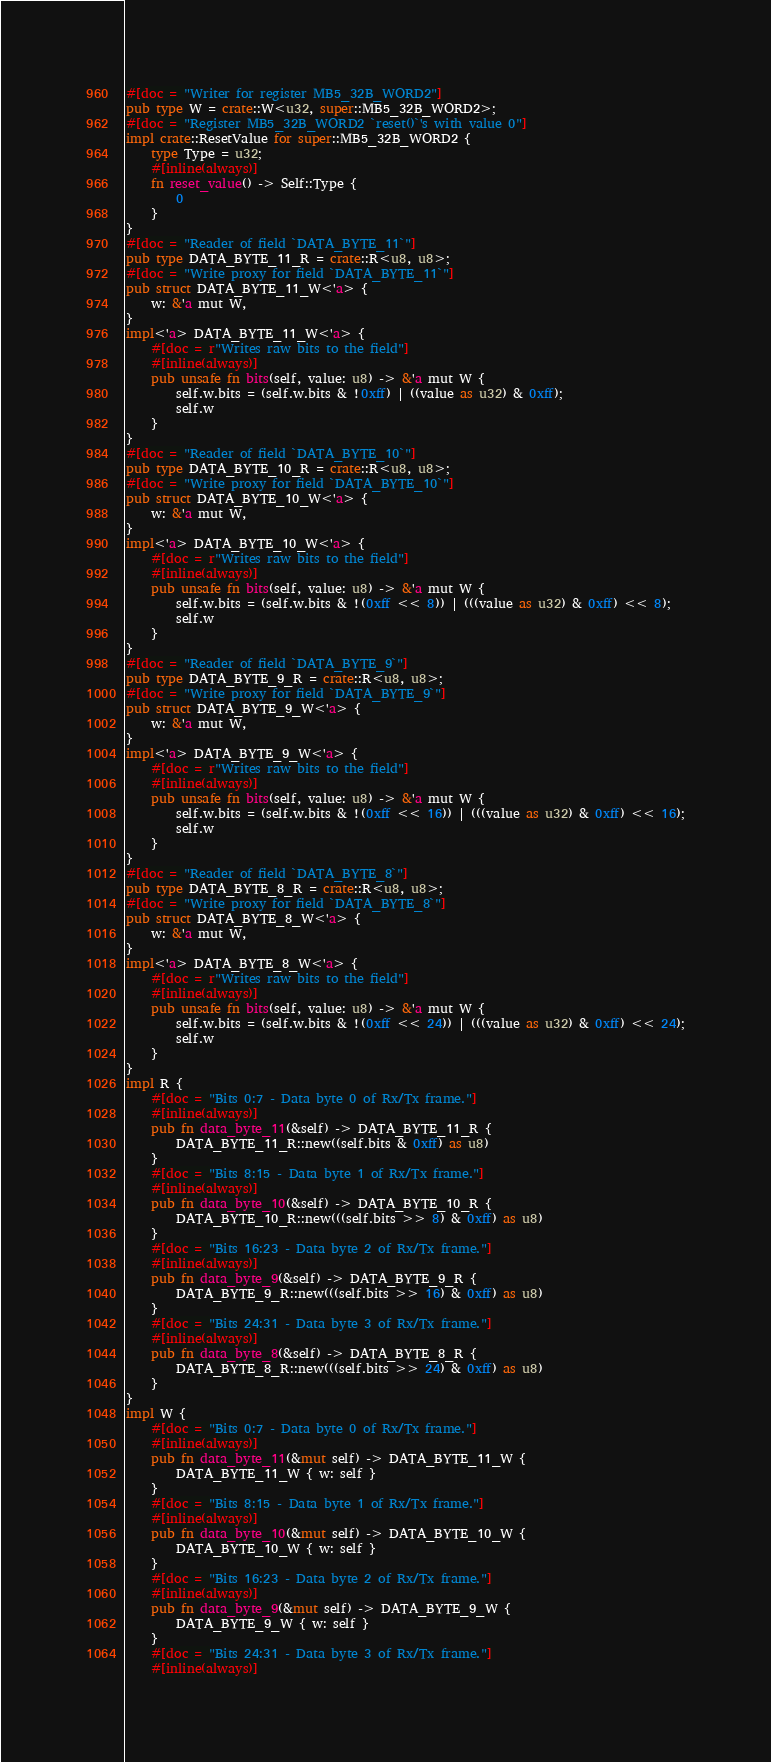<code> <loc_0><loc_0><loc_500><loc_500><_Rust_>#[doc = "Writer for register MB5_32B_WORD2"]
pub type W = crate::W<u32, super::MB5_32B_WORD2>;
#[doc = "Register MB5_32B_WORD2 `reset()`'s with value 0"]
impl crate::ResetValue for super::MB5_32B_WORD2 {
    type Type = u32;
    #[inline(always)]
    fn reset_value() -> Self::Type {
        0
    }
}
#[doc = "Reader of field `DATA_BYTE_11`"]
pub type DATA_BYTE_11_R = crate::R<u8, u8>;
#[doc = "Write proxy for field `DATA_BYTE_11`"]
pub struct DATA_BYTE_11_W<'a> {
    w: &'a mut W,
}
impl<'a> DATA_BYTE_11_W<'a> {
    #[doc = r"Writes raw bits to the field"]
    #[inline(always)]
    pub unsafe fn bits(self, value: u8) -> &'a mut W {
        self.w.bits = (self.w.bits & !0xff) | ((value as u32) & 0xff);
        self.w
    }
}
#[doc = "Reader of field `DATA_BYTE_10`"]
pub type DATA_BYTE_10_R = crate::R<u8, u8>;
#[doc = "Write proxy for field `DATA_BYTE_10`"]
pub struct DATA_BYTE_10_W<'a> {
    w: &'a mut W,
}
impl<'a> DATA_BYTE_10_W<'a> {
    #[doc = r"Writes raw bits to the field"]
    #[inline(always)]
    pub unsafe fn bits(self, value: u8) -> &'a mut W {
        self.w.bits = (self.w.bits & !(0xff << 8)) | (((value as u32) & 0xff) << 8);
        self.w
    }
}
#[doc = "Reader of field `DATA_BYTE_9`"]
pub type DATA_BYTE_9_R = crate::R<u8, u8>;
#[doc = "Write proxy for field `DATA_BYTE_9`"]
pub struct DATA_BYTE_9_W<'a> {
    w: &'a mut W,
}
impl<'a> DATA_BYTE_9_W<'a> {
    #[doc = r"Writes raw bits to the field"]
    #[inline(always)]
    pub unsafe fn bits(self, value: u8) -> &'a mut W {
        self.w.bits = (self.w.bits & !(0xff << 16)) | (((value as u32) & 0xff) << 16);
        self.w
    }
}
#[doc = "Reader of field `DATA_BYTE_8`"]
pub type DATA_BYTE_8_R = crate::R<u8, u8>;
#[doc = "Write proxy for field `DATA_BYTE_8`"]
pub struct DATA_BYTE_8_W<'a> {
    w: &'a mut W,
}
impl<'a> DATA_BYTE_8_W<'a> {
    #[doc = r"Writes raw bits to the field"]
    #[inline(always)]
    pub unsafe fn bits(self, value: u8) -> &'a mut W {
        self.w.bits = (self.w.bits & !(0xff << 24)) | (((value as u32) & 0xff) << 24);
        self.w
    }
}
impl R {
    #[doc = "Bits 0:7 - Data byte 0 of Rx/Tx frame."]
    #[inline(always)]
    pub fn data_byte_11(&self) -> DATA_BYTE_11_R {
        DATA_BYTE_11_R::new((self.bits & 0xff) as u8)
    }
    #[doc = "Bits 8:15 - Data byte 1 of Rx/Tx frame."]
    #[inline(always)]
    pub fn data_byte_10(&self) -> DATA_BYTE_10_R {
        DATA_BYTE_10_R::new(((self.bits >> 8) & 0xff) as u8)
    }
    #[doc = "Bits 16:23 - Data byte 2 of Rx/Tx frame."]
    #[inline(always)]
    pub fn data_byte_9(&self) -> DATA_BYTE_9_R {
        DATA_BYTE_9_R::new(((self.bits >> 16) & 0xff) as u8)
    }
    #[doc = "Bits 24:31 - Data byte 3 of Rx/Tx frame."]
    #[inline(always)]
    pub fn data_byte_8(&self) -> DATA_BYTE_8_R {
        DATA_BYTE_8_R::new(((self.bits >> 24) & 0xff) as u8)
    }
}
impl W {
    #[doc = "Bits 0:7 - Data byte 0 of Rx/Tx frame."]
    #[inline(always)]
    pub fn data_byte_11(&mut self) -> DATA_BYTE_11_W {
        DATA_BYTE_11_W { w: self }
    }
    #[doc = "Bits 8:15 - Data byte 1 of Rx/Tx frame."]
    #[inline(always)]
    pub fn data_byte_10(&mut self) -> DATA_BYTE_10_W {
        DATA_BYTE_10_W { w: self }
    }
    #[doc = "Bits 16:23 - Data byte 2 of Rx/Tx frame."]
    #[inline(always)]
    pub fn data_byte_9(&mut self) -> DATA_BYTE_9_W {
        DATA_BYTE_9_W { w: self }
    }
    #[doc = "Bits 24:31 - Data byte 3 of Rx/Tx frame."]
    #[inline(always)]</code> 